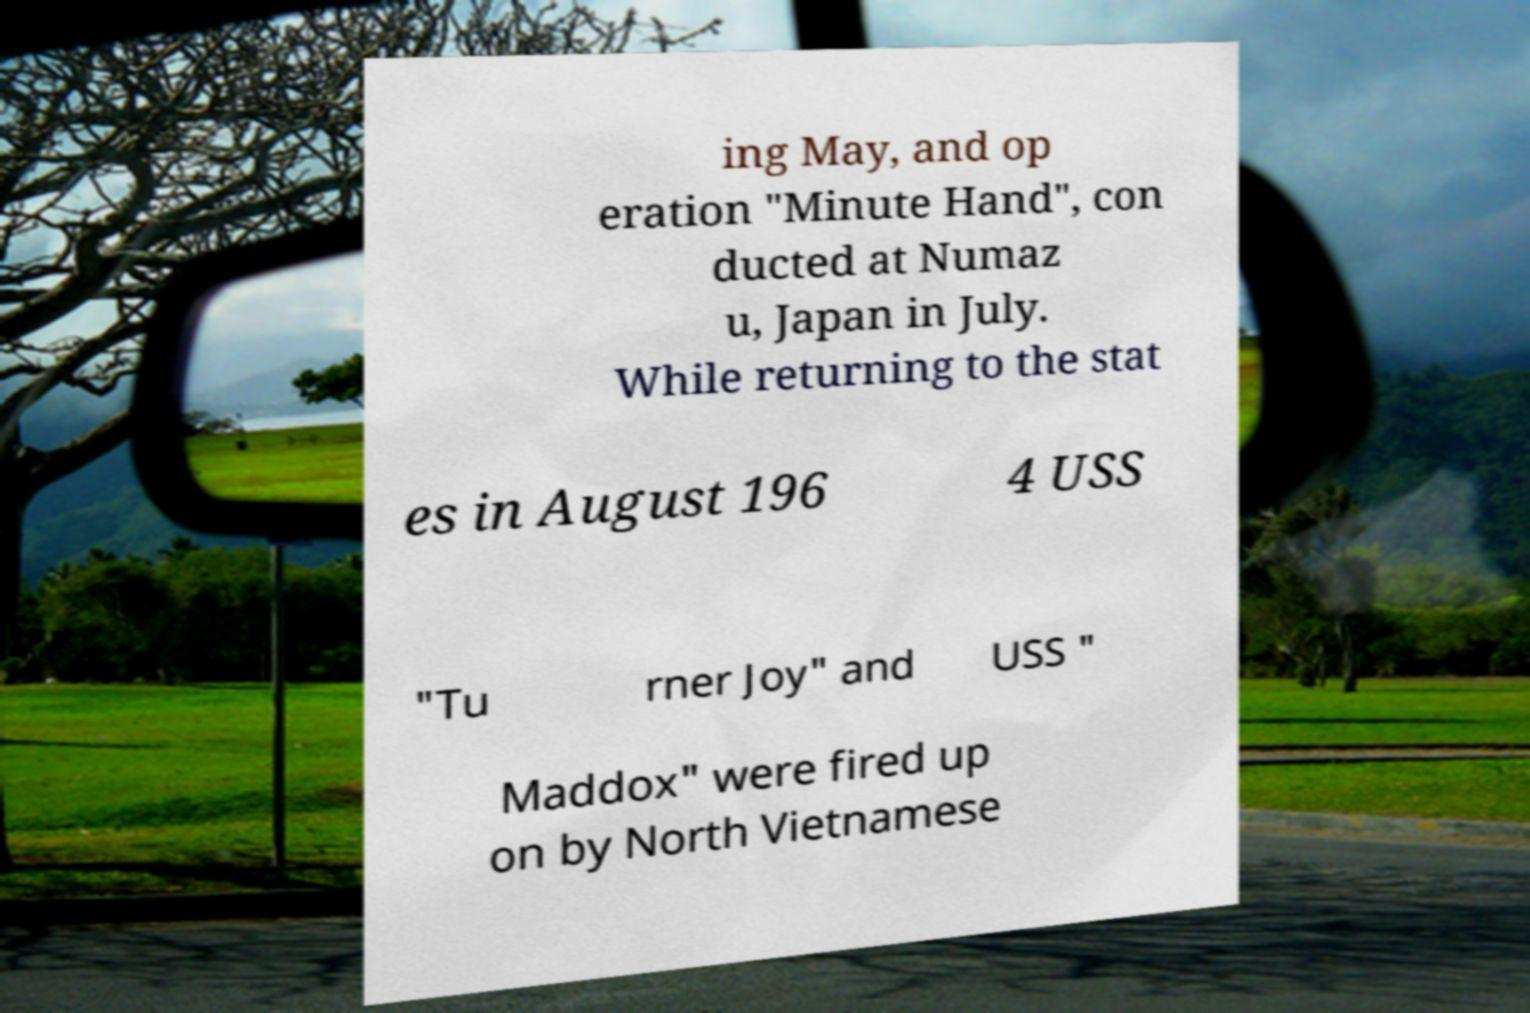What messages or text are displayed in this image? I need them in a readable, typed format. ing May, and op eration "Minute Hand", con ducted at Numaz u, Japan in July. While returning to the stat es in August 196 4 USS "Tu rner Joy" and USS " Maddox" were fired up on by North Vietnamese 